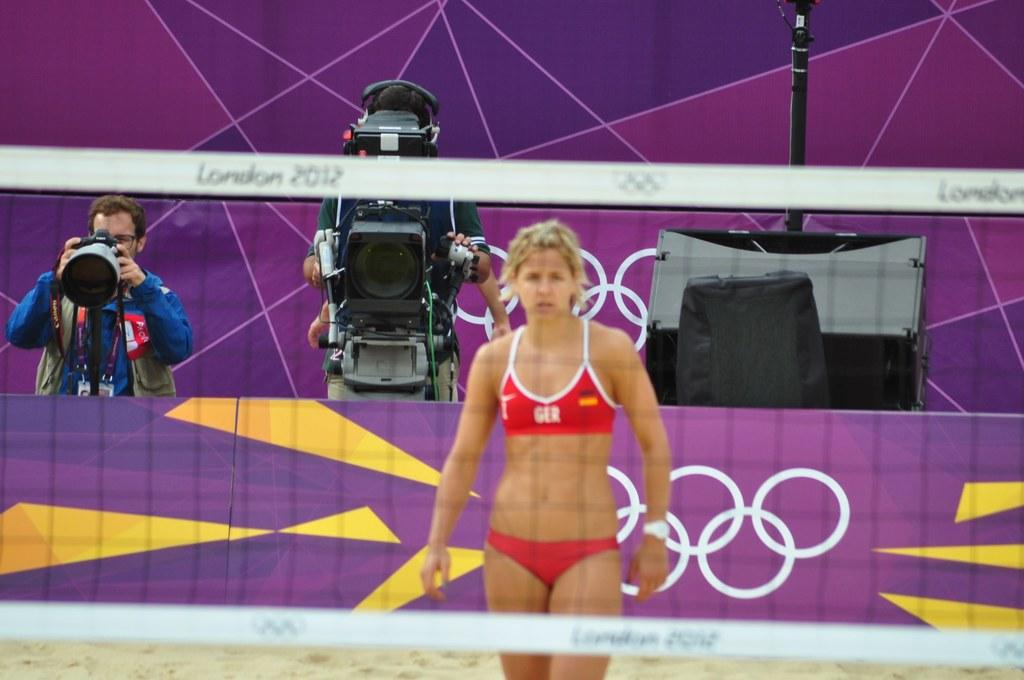How many people are present in the image? There are three people in the image. What are two of the people doing in the image? Two of the people are holding cameras. What is the opinion of the person holding the rice in the image? There is no rice present in the image, and therefore no one can have an opinion about it. 